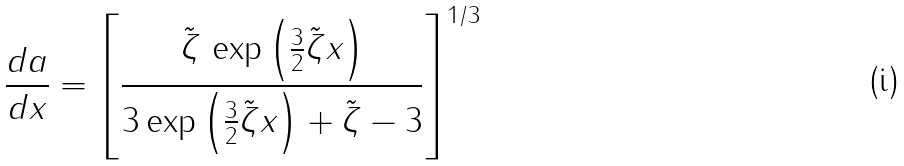Convert formula to latex. <formula><loc_0><loc_0><loc_500><loc_500>\frac { d a } { d x } = \left [ \frac { \tilde { \zeta } \, \exp \left ( \frac { 3 } { 2 } \tilde { \zeta } x \right ) } { 3 \exp \left ( \frac { 3 } { 2 } \tilde { \zeta } x \right ) + \tilde { \zeta } - 3 } \right ] ^ { 1 / 3 }</formula> 